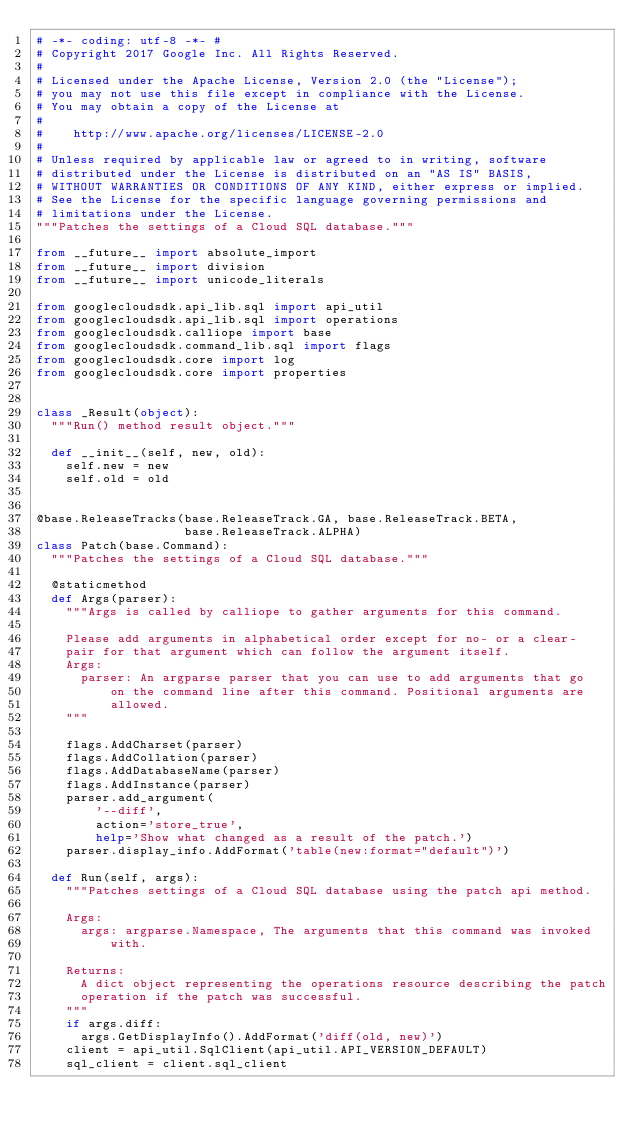<code> <loc_0><loc_0><loc_500><loc_500><_Python_># -*- coding: utf-8 -*- #
# Copyright 2017 Google Inc. All Rights Reserved.
#
# Licensed under the Apache License, Version 2.0 (the "License");
# you may not use this file except in compliance with the License.
# You may obtain a copy of the License at
#
#    http://www.apache.org/licenses/LICENSE-2.0
#
# Unless required by applicable law or agreed to in writing, software
# distributed under the License is distributed on an "AS IS" BASIS,
# WITHOUT WARRANTIES OR CONDITIONS OF ANY KIND, either express or implied.
# See the License for the specific language governing permissions and
# limitations under the License.
"""Patches the settings of a Cloud SQL database."""

from __future__ import absolute_import
from __future__ import division
from __future__ import unicode_literals

from googlecloudsdk.api_lib.sql import api_util
from googlecloudsdk.api_lib.sql import operations
from googlecloudsdk.calliope import base
from googlecloudsdk.command_lib.sql import flags
from googlecloudsdk.core import log
from googlecloudsdk.core import properties


class _Result(object):
  """Run() method result object."""

  def __init__(self, new, old):
    self.new = new
    self.old = old


@base.ReleaseTracks(base.ReleaseTrack.GA, base.ReleaseTrack.BETA,
                    base.ReleaseTrack.ALPHA)
class Patch(base.Command):
  """Patches the settings of a Cloud SQL database."""

  @staticmethod
  def Args(parser):
    """Args is called by calliope to gather arguments for this command.

    Please add arguments in alphabetical order except for no- or a clear-
    pair for that argument which can follow the argument itself.
    Args:
      parser: An argparse parser that you can use to add arguments that go
          on the command line after this command. Positional arguments are
          allowed.
    """

    flags.AddCharset(parser)
    flags.AddCollation(parser)
    flags.AddDatabaseName(parser)
    flags.AddInstance(parser)
    parser.add_argument(
        '--diff',
        action='store_true',
        help='Show what changed as a result of the patch.')
    parser.display_info.AddFormat('table(new:format="default")')

  def Run(self, args):
    """Patches settings of a Cloud SQL database using the patch api method.

    Args:
      args: argparse.Namespace, The arguments that this command was invoked
          with.

    Returns:
      A dict object representing the operations resource describing the patch
      operation if the patch was successful.
    """
    if args.diff:
      args.GetDisplayInfo().AddFormat('diff(old, new)')
    client = api_util.SqlClient(api_util.API_VERSION_DEFAULT)
    sql_client = client.sql_client</code> 